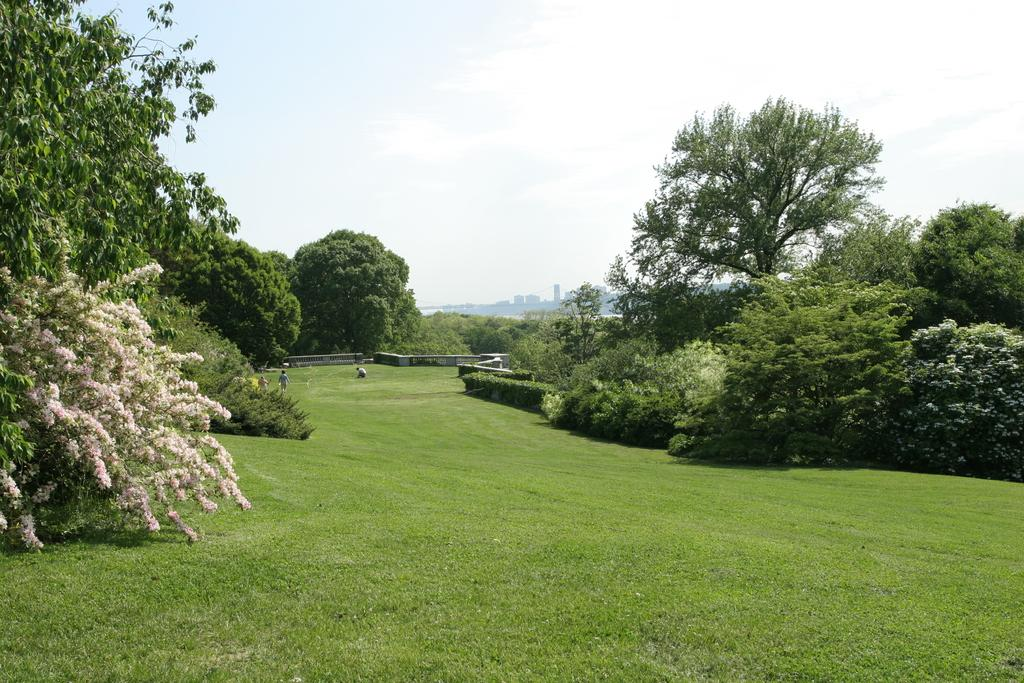What type of ground covering is visible in the image? The ground is covered with grass. What type of vegetation can be seen in the image? There are plants and trees visible in the image. What can be seen in the background of the image? There are people and buildings visible in the background. What is visible in the sky in the image? The sky is visible in the image. Can you see the crown on the person's head in the image? There is no crown visible in the image. Who has the authority in the image? The image does not depict any specific authority figure. 